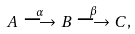Convert formula to latex. <formula><loc_0><loc_0><loc_500><loc_500>A \stackrel { \alpha } { \longrightarrow } B \stackrel { \beta } { \longrightarrow } C ,</formula> 